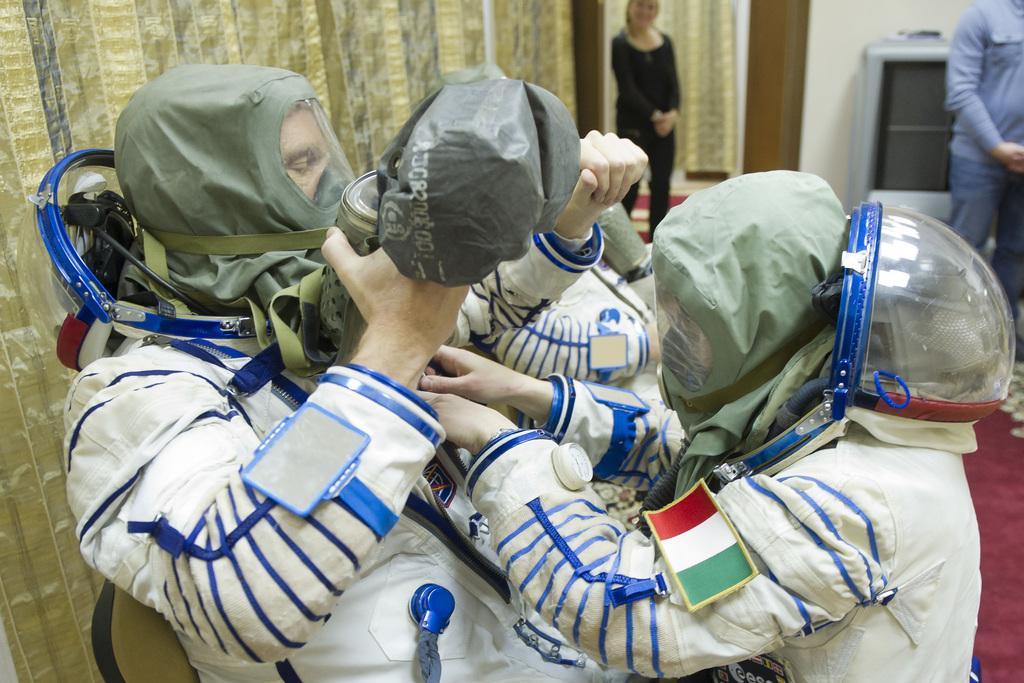In one or two sentences, can you explain what this image depicts? This picture is clicked inside. In the foreground we can see the group of persons seems to be fighting and wearing the jackets and helmets. In the background we can see the curtain, wall, television and the ground is covered with the floor mat and we can see the two persons standing on the ground and we can see the wall. 